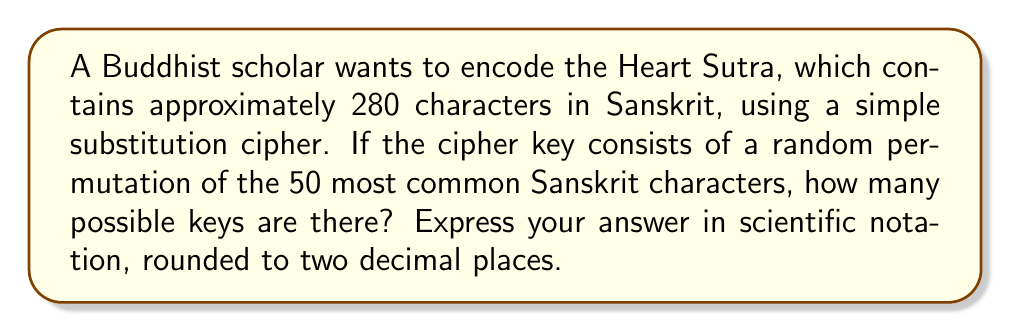Solve this math problem. To solve this problem, we need to follow these steps:

1. Understand the concept of permutations:
   A permutation is an arrangement of objects in a specific order. The number of permutations of n distinct objects is given by n!.

2. Identify the number of characters in our key:
   The cipher key consists of a random permutation of the 50 most common Sanskrit characters.

3. Calculate the number of possible permutations:
   The number of possible keys is equal to the number of permutations of 50 characters.
   This is given by 50!

4. Compute 50!:
   $$50! = 1 \times 2 \times 3 \times ... \times 49 \times 50$$
   This is a very large number, so we need to use scientific notation.

5. Use Stirling's approximation to estimate 50!:
   Stirling's approximation states that for large n:
   $$n! \approx \sqrt{2\pi n} \left(\frac{n}{e}\right)^n$$

   Let's calculate this for n = 50:
   $$50! \approx \sqrt{2\pi \cdot 50} \left(\frac{50}{e}\right)^{50}$$

6. Compute the result:
   $$50! \approx \sqrt{314.159} \cdot (18.3939)^{50}$$
   $$50! \approx 17.7245 \cdot (3.0461 \times 10^{64})$$
   $$50! \approx 5.3990 \times 10^{64}$$

7. Round to two decimal places in scientific notation:
   $$50! \approx 5.40 \times 10^{64}$$

This represents the number of possible keys for encoding the Heart Sutra using the described substitution cipher.
Answer: $5.40 \times 10^{64}$ 